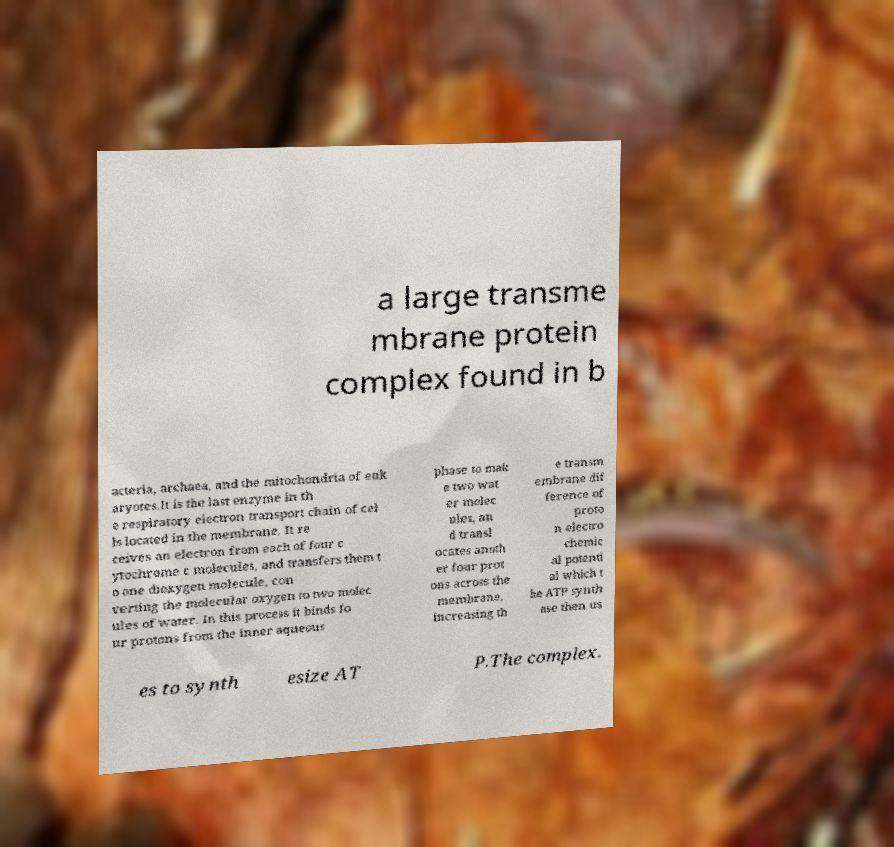Please read and relay the text visible in this image. What does it say? a large transme mbrane protein complex found in b acteria, archaea, and the mitochondria of euk aryotes.It is the last enzyme in th e respiratory electron transport chain of cel ls located in the membrane. It re ceives an electron from each of four c ytochrome c molecules, and transfers them t o one dioxygen molecule, con verting the molecular oxygen to two molec ules of water. In this process it binds fo ur protons from the inner aqueous phase to mak e two wat er molec ules, an d transl ocates anoth er four prot ons across the membrane, increasing th e transm embrane dif ference of proto n electro chemic al potenti al which t he ATP synth ase then us es to synth esize AT P.The complex. 